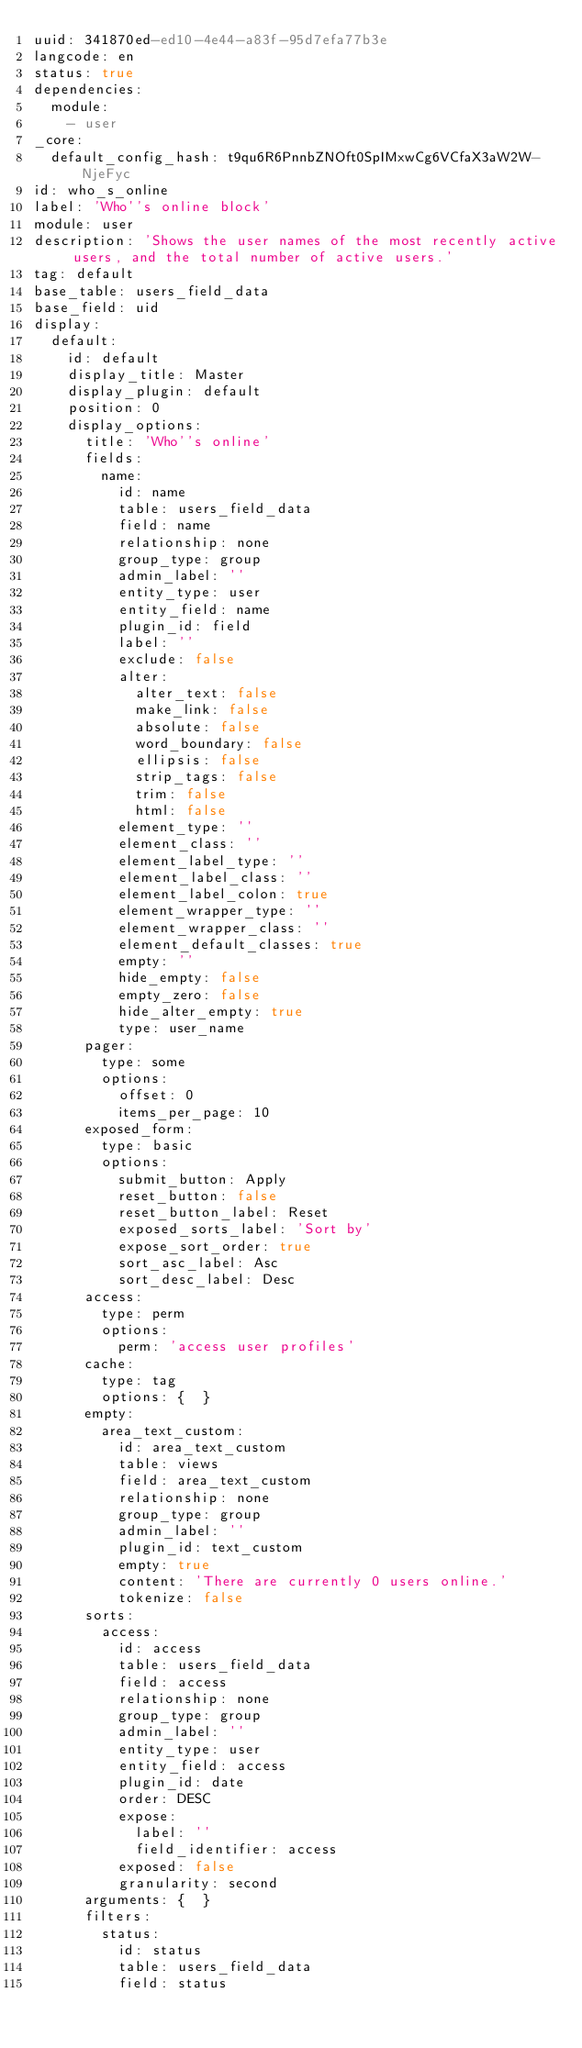<code> <loc_0><loc_0><loc_500><loc_500><_YAML_>uuid: 341870ed-ed10-4e44-a83f-95d7efa77b3e
langcode: en
status: true
dependencies:
  module:
    - user
_core:
  default_config_hash: t9qu6R6PnnbZNOft0SpIMxwCg6VCfaX3aW2W-NjeFyc
id: who_s_online
label: 'Who''s online block'
module: user
description: 'Shows the user names of the most recently active users, and the total number of active users.'
tag: default
base_table: users_field_data
base_field: uid
display:
  default:
    id: default
    display_title: Master
    display_plugin: default
    position: 0
    display_options:
      title: 'Who''s online'
      fields:
        name:
          id: name
          table: users_field_data
          field: name
          relationship: none
          group_type: group
          admin_label: ''
          entity_type: user
          entity_field: name
          plugin_id: field
          label: ''
          exclude: false
          alter:
            alter_text: false
            make_link: false
            absolute: false
            word_boundary: false
            ellipsis: false
            strip_tags: false
            trim: false
            html: false
          element_type: ''
          element_class: ''
          element_label_type: ''
          element_label_class: ''
          element_label_colon: true
          element_wrapper_type: ''
          element_wrapper_class: ''
          element_default_classes: true
          empty: ''
          hide_empty: false
          empty_zero: false
          hide_alter_empty: true
          type: user_name
      pager:
        type: some
        options:
          offset: 0
          items_per_page: 10
      exposed_form:
        type: basic
        options:
          submit_button: Apply
          reset_button: false
          reset_button_label: Reset
          exposed_sorts_label: 'Sort by'
          expose_sort_order: true
          sort_asc_label: Asc
          sort_desc_label: Desc
      access:
        type: perm
        options:
          perm: 'access user profiles'
      cache:
        type: tag
        options: {  }
      empty:
        area_text_custom:
          id: area_text_custom
          table: views
          field: area_text_custom
          relationship: none
          group_type: group
          admin_label: ''
          plugin_id: text_custom
          empty: true
          content: 'There are currently 0 users online.'
          tokenize: false
      sorts:
        access:
          id: access
          table: users_field_data
          field: access
          relationship: none
          group_type: group
          admin_label: ''
          entity_type: user
          entity_field: access
          plugin_id: date
          order: DESC
          expose:
            label: ''
            field_identifier: access
          exposed: false
          granularity: second
      arguments: {  }
      filters:
        status:
          id: status
          table: users_field_data
          field: status</code> 